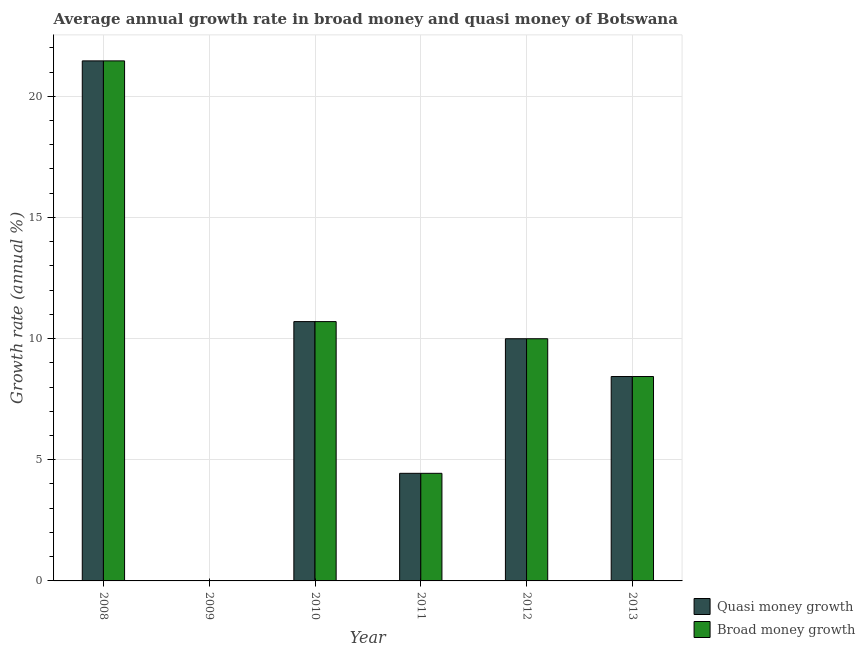How many different coloured bars are there?
Provide a succinct answer. 2. Are the number of bars per tick equal to the number of legend labels?
Provide a succinct answer. No. Are the number of bars on each tick of the X-axis equal?
Give a very brief answer. No. What is the label of the 1st group of bars from the left?
Your answer should be very brief. 2008. In how many cases, is the number of bars for a given year not equal to the number of legend labels?
Offer a very short reply. 1. What is the annual growth rate in broad money in 2010?
Give a very brief answer. 10.7. Across all years, what is the maximum annual growth rate in quasi money?
Offer a very short reply. 21.46. Across all years, what is the minimum annual growth rate in broad money?
Keep it short and to the point. 0. What is the total annual growth rate in quasi money in the graph?
Give a very brief answer. 55.03. What is the difference between the annual growth rate in broad money in 2012 and that in 2013?
Your answer should be compact. 1.56. What is the difference between the annual growth rate in quasi money in 2013 and the annual growth rate in broad money in 2012?
Give a very brief answer. -1.56. What is the average annual growth rate in broad money per year?
Offer a terse response. 9.17. In the year 2013, what is the difference between the annual growth rate in quasi money and annual growth rate in broad money?
Your answer should be compact. 0. What is the ratio of the annual growth rate in broad money in 2011 to that in 2013?
Ensure brevity in your answer.  0.53. Is the annual growth rate in broad money in 2010 less than that in 2013?
Your answer should be compact. No. What is the difference between the highest and the second highest annual growth rate in quasi money?
Keep it short and to the point. 10.76. What is the difference between the highest and the lowest annual growth rate in quasi money?
Ensure brevity in your answer.  21.46. In how many years, is the annual growth rate in broad money greater than the average annual growth rate in broad money taken over all years?
Offer a very short reply. 3. Is the sum of the annual growth rate in quasi money in 2008 and 2013 greater than the maximum annual growth rate in broad money across all years?
Provide a succinct answer. Yes. What is the difference between two consecutive major ticks on the Y-axis?
Provide a short and direct response. 5. Are the values on the major ticks of Y-axis written in scientific E-notation?
Keep it short and to the point. No. Does the graph contain grids?
Your response must be concise. Yes. Where does the legend appear in the graph?
Give a very brief answer. Bottom right. What is the title of the graph?
Provide a succinct answer. Average annual growth rate in broad money and quasi money of Botswana. Does "Personal remittances" appear as one of the legend labels in the graph?
Keep it short and to the point. No. What is the label or title of the Y-axis?
Your response must be concise. Growth rate (annual %). What is the Growth rate (annual %) in Quasi money growth in 2008?
Offer a terse response. 21.46. What is the Growth rate (annual %) in Broad money growth in 2008?
Ensure brevity in your answer.  21.46. What is the Growth rate (annual %) in Quasi money growth in 2009?
Your response must be concise. 0. What is the Growth rate (annual %) in Broad money growth in 2009?
Give a very brief answer. 0. What is the Growth rate (annual %) in Quasi money growth in 2010?
Your response must be concise. 10.7. What is the Growth rate (annual %) in Broad money growth in 2010?
Ensure brevity in your answer.  10.7. What is the Growth rate (annual %) in Quasi money growth in 2011?
Your answer should be compact. 4.44. What is the Growth rate (annual %) in Broad money growth in 2011?
Your answer should be very brief. 4.44. What is the Growth rate (annual %) of Quasi money growth in 2012?
Your response must be concise. 9.99. What is the Growth rate (annual %) in Broad money growth in 2012?
Offer a very short reply. 9.99. What is the Growth rate (annual %) in Quasi money growth in 2013?
Make the answer very short. 8.43. What is the Growth rate (annual %) of Broad money growth in 2013?
Give a very brief answer. 8.43. Across all years, what is the maximum Growth rate (annual %) in Quasi money growth?
Your response must be concise. 21.46. Across all years, what is the maximum Growth rate (annual %) of Broad money growth?
Keep it short and to the point. 21.46. Across all years, what is the minimum Growth rate (annual %) in Quasi money growth?
Offer a terse response. 0. What is the total Growth rate (annual %) of Quasi money growth in the graph?
Your response must be concise. 55.03. What is the total Growth rate (annual %) of Broad money growth in the graph?
Provide a succinct answer. 55.03. What is the difference between the Growth rate (annual %) of Quasi money growth in 2008 and that in 2010?
Provide a short and direct response. 10.76. What is the difference between the Growth rate (annual %) in Broad money growth in 2008 and that in 2010?
Your response must be concise. 10.76. What is the difference between the Growth rate (annual %) of Quasi money growth in 2008 and that in 2011?
Your answer should be very brief. 17.02. What is the difference between the Growth rate (annual %) of Broad money growth in 2008 and that in 2011?
Keep it short and to the point. 17.02. What is the difference between the Growth rate (annual %) of Quasi money growth in 2008 and that in 2012?
Keep it short and to the point. 11.47. What is the difference between the Growth rate (annual %) of Broad money growth in 2008 and that in 2012?
Offer a very short reply. 11.47. What is the difference between the Growth rate (annual %) in Quasi money growth in 2008 and that in 2013?
Provide a succinct answer. 13.03. What is the difference between the Growth rate (annual %) in Broad money growth in 2008 and that in 2013?
Provide a short and direct response. 13.03. What is the difference between the Growth rate (annual %) of Quasi money growth in 2010 and that in 2011?
Your answer should be compact. 6.26. What is the difference between the Growth rate (annual %) of Broad money growth in 2010 and that in 2011?
Offer a very short reply. 6.26. What is the difference between the Growth rate (annual %) in Quasi money growth in 2010 and that in 2012?
Your answer should be very brief. 0.71. What is the difference between the Growth rate (annual %) in Broad money growth in 2010 and that in 2012?
Give a very brief answer. 0.71. What is the difference between the Growth rate (annual %) of Quasi money growth in 2010 and that in 2013?
Provide a succinct answer. 2.27. What is the difference between the Growth rate (annual %) of Broad money growth in 2010 and that in 2013?
Offer a terse response. 2.27. What is the difference between the Growth rate (annual %) in Quasi money growth in 2011 and that in 2012?
Make the answer very short. -5.55. What is the difference between the Growth rate (annual %) in Broad money growth in 2011 and that in 2012?
Provide a short and direct response. -5.55. What is the difference between the Growth rate (annual %) in Quasi money growth in 2011 and that in 2013?
Give a very brief answer. -3.99. What is the difference between the Growth rate (annual %) in Broad money growth in 2011 and that in 2013?
Give a very brief answer. -3.99. What is the difference between the Growth rate (annual %) in Quasi money growth in 2012 and that in 2013?
Give a very brief answer. 1.56. What is the difference between the Growth rate (annual %) in Broad money growth in 2012 and that in 2013?
Provide a succinct answer. 1.56. What is the difference between the Growth rate (annual %) in Quasi money growth in 2008 and the Growth rate (annual %) in Broad money growth in 2010?
Provide a short and direct response. 10.76. What is the difference between the Growth rate (annual %) of Quasi money growth in 2008 and the Growth rate (annual %) of Broad money growth in 2011?
Your response must be concise. 17.02. What is the difference between the Growth rate (annual %) of Quasi money growth in 2008 and the Growth rate (annual %) of Broad money growth in 2012?
Offer a terse response. 11.47. What is the difference between the Growth rate (annual %) of Quasi money growth in 2008 and the Growth rate (annual %) of Broad money growth in 2013?
Your answer should be compact. 13.03. What is the difference between the Growth rate (annual %) of Quasi money growth in 2010 and the Growth rate (annual %) of Broad money growth in 2011?
Your answer should be very brief. 6.26. What is the difference between the Growth rate (annual %) in Quasi money growth in 2010 and the Growth rate (annual %) in Broad money growth in 2012?
Provide a short and direct response. 0.71. What is the difference between the Growth rate (annual %) of Quasi money growth in 2010 and the Growth rate (annual %) of Broad money growth in 2013?
Make the answer very short. 2.27. What is the difference between the Growth rate (annual %) in Quasi money growth in 2011 and the Growth rate (annual %) in Broad money growth in 2012?
Your answer should be compact. -5.55. What is the difference between the Growth rate (annual %) in Quasi money growth in 2011 and the Growth rate (annual %) in Broad money growth in 2013?
Provide a succinct answer. -3.99. What is the difference between the Growth rate (annual %) in Quasi money growth in 2012 and the Growth rate (annual %) in Broad money growth in 2013?
Give a very brief answer. 1.56. What is the average Growth rate (annual %) of Quasi money growth per year?
Give a very brief answer. 9.17. What is the average Growth rate (annual %) of Broad money growth per year?
Give a very brief answer. 9.17. In the year 2013, what is the difference between the Growth rate (annual %) of Quasi money growth and Growth rate (annual %) of Broad money growth?
Your answer should be compact. 0. What is the ratio of the Growth rate (annual %) of Quasi money growth in 2008 to that in 2010?
Your response must be concise. 2.01. What is the ratio of the Growth rate (annual %) of Broad money growth in 2008 to that in 2010?
Your answer should be very brief. 2.01. What is the ratio of the Growth rate (annual %) of Quasi money growth in 2008 to that in 2011?
Offer a very short reply. 4.83. What is the ratio of the Growth rate (annual %) in Broad money growth in 2008 to that in 2011?
Provide a succinct answer. 4.83. What is the ratio of the Growth rate (annual %) of Quasi money growth in 2008 to that in 2012?
Offer a very short reply. 2.15. What is the ratio of the Growth rate (annual %) of Broad money growth in 2008 to that in 2012?
Provide a short and direct response. 2.15. What is the ratio of the Growth rate (annual %) in Quasi money growth in 2008 to that in 2013?
Offer a very short reply. 2.54. What is the ratio of the Growth rate (annual %) in Broad money growth in 2008 to that in 2013?
Offer a terse response. 2.54. What is the ratio of the Growth rate (annual %) of Quasi money growth in 2010 to that in 2011?
Your response must be concise. 2.41. What is the ratio of the Growth rate (annual %) in Broad money growth in 2010 to that in 2011?
Provide a succinct answer. 2.41. What is the ratio of the Growth rate (annual %) in Quasi money growth in 2010 to that in 2012?
Offer a very short reply. 1.07. What is the ratio of the Growth rate (annual %) in Broad money growth in 2010 to that in 2012?
Offer a terse response. 1.07. What is the ratio of the Growth rate (annual %) in Quasi money growth in 2010 to that in 2013?
Your answer should be compact. 1.27. What is the ratio of the Growth rate (annual %) of Broad money growth in 2010 to that in 2013?
Provide a short and direct response. 1.27. What is the ratio of the Growth rate (annual %) of Quasi money growth in 2011 to that in 2012?
Your answer should be very brief. 0.44. What is the ratio of the Growth rate (annual %) of Broad money growth in 2011 to that in 2012?
Keep it short and to the point. 0.44. What is the ratio of the Growth rate (annual %) in Quasi money growth in 2011 to that in 2013?
Provide a succinct answer. 0.53. What is the ratio of the Growth rate (annual %) of Broad money growth in 2011 to that in 2013?
Ensure brevity in your answer.  0.53. What is the ratio of the Growth rate (annual %) in Quasi money growth in 2012 to that in 2013?
Provide a short and direct response. 1.18. What is the ratio of the Growth rate (annual %) in Broad money growth in 2012 to that in 2013?
Your answer should be very brief. 1.18. What is the difference between the highest and the second highest Growth rate (annual %) in Quasi money growth?
Ensure brevity in your answer.  10.76. What is the difference between the highest and the second highest Growth rate (annual %) in Broad money growth?
Your answer should be compact. 10.76. What is the difference between the highest and the lowest Growth rate (annual %) in Quasi money growth?
Provide a succinct answer. 21.46. What is the difference between the highest and the lowest Growth rate (annual %) in Broad money growth?
Provide a short and direct response. 21.46. 